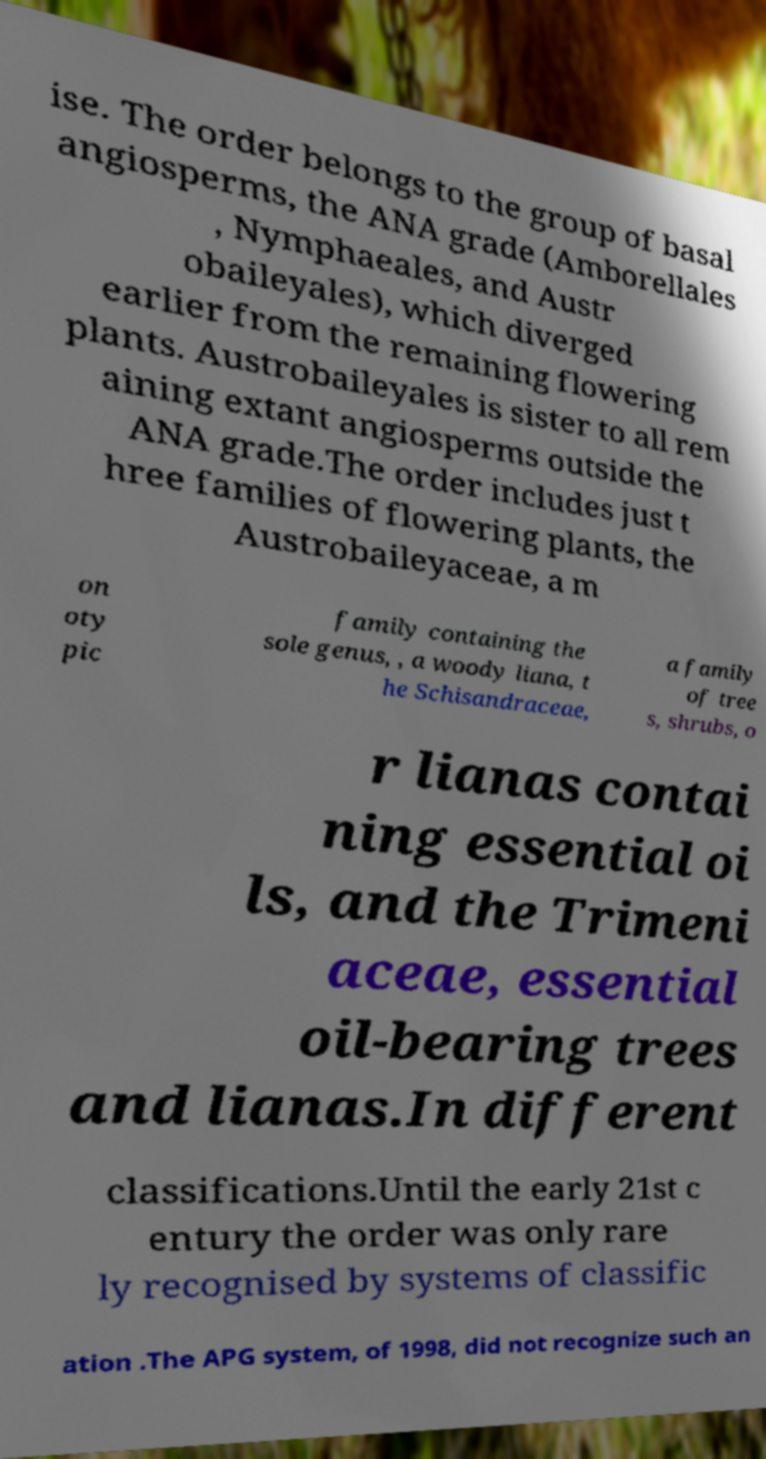For documentation purposes, I need the text within this image transcribed. Could you provide that? ise. The order belongs to the group of basal angiosperms, the ANA grade (Amborellales , Nymphaeales, and Austr obaileyales), which diverged earlier from the remaining flowering plants. Austrobaileyales is sister to all rem aining extant angiosperms outside the ANA grade.The order includes just t hree families of flowering plants, the Austrobaileyaceae, a m on oty pic family containing the sole genus, , a woody liana, t he Schisandraceae, a family of tree s, shrubs, o r lianas contai ning essential oi ls, and the Trimeni aceae, essential oil-bearing trees and lianas.In different classifications.Until the early 21st c entury the order was only rare ly recognised by systems of classific ation .The APG system, of 1998, did not recognize such an 